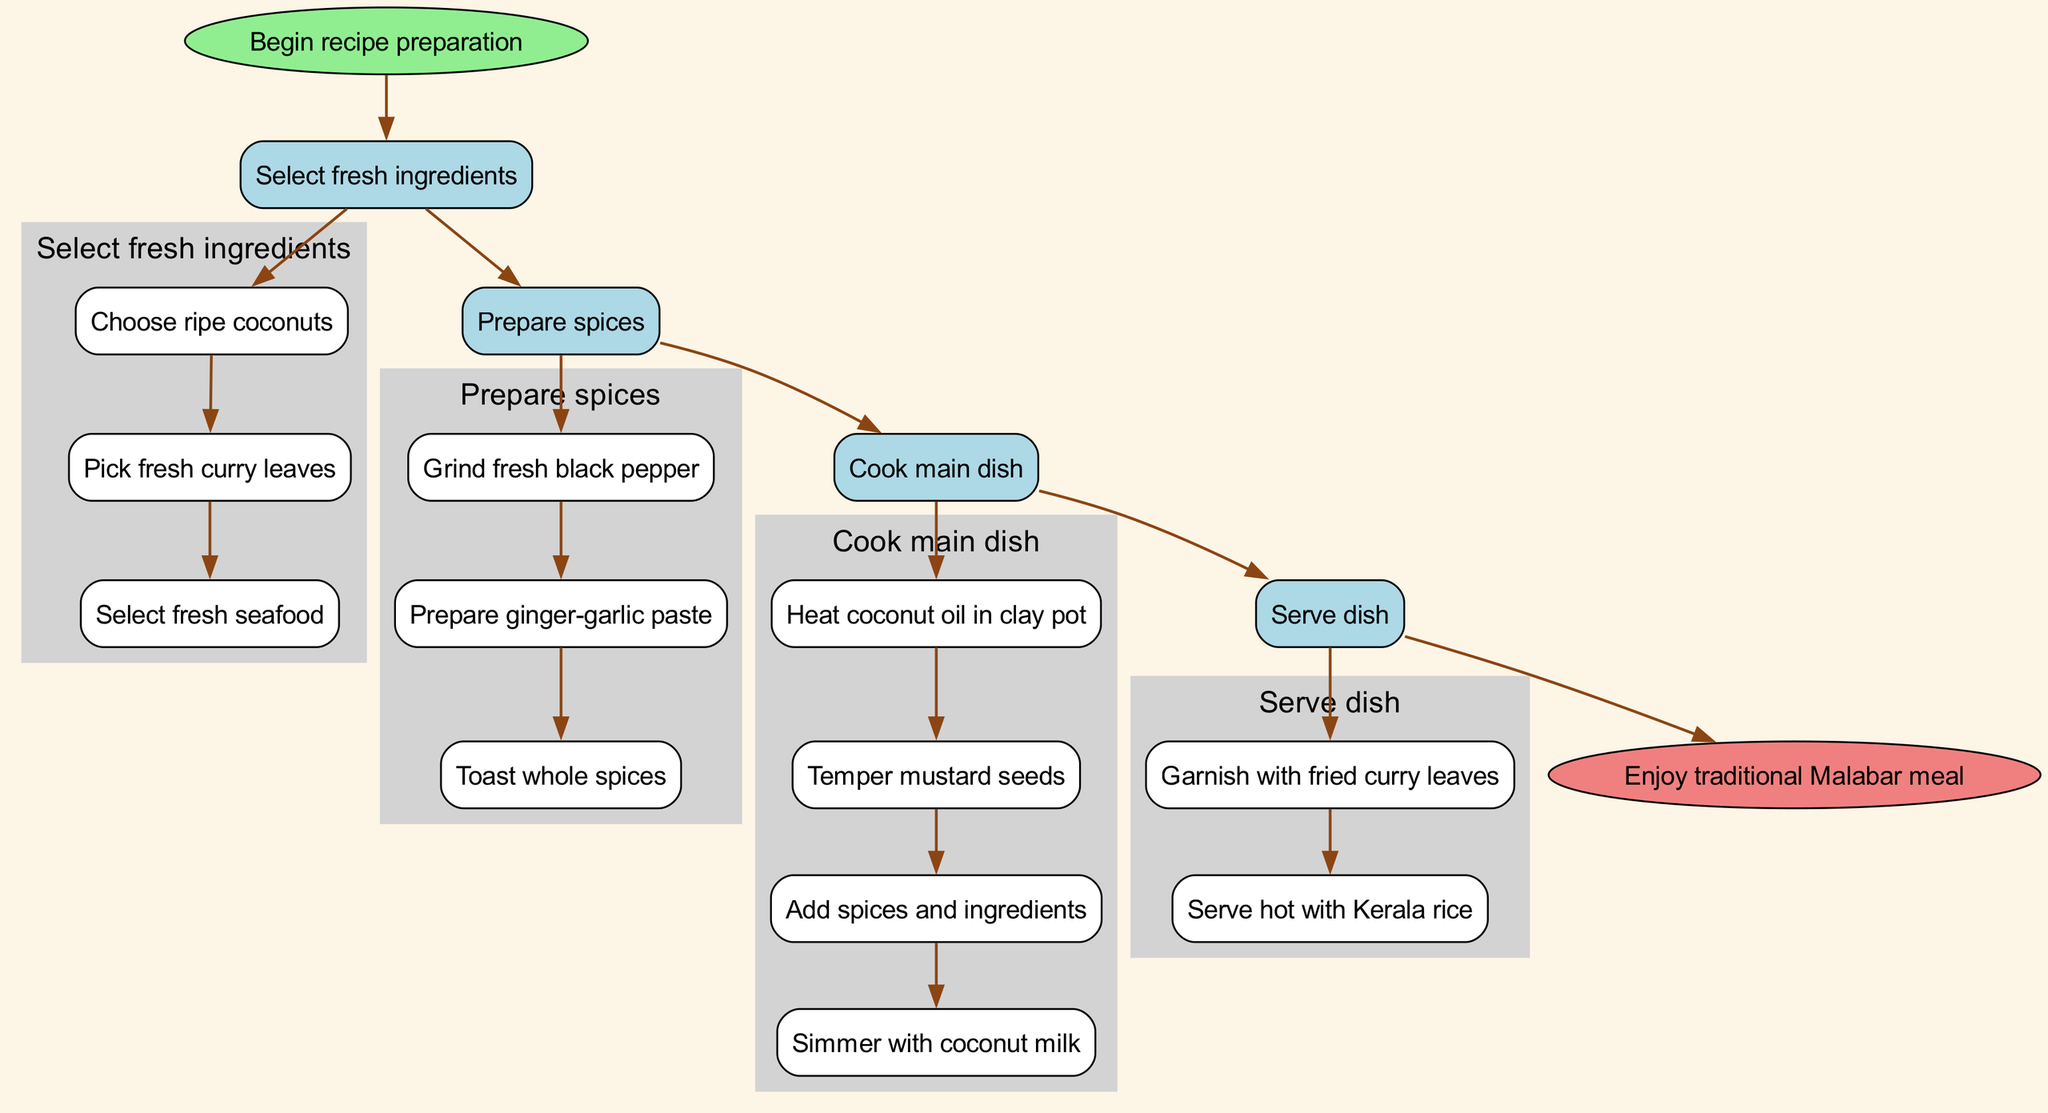What is the first step in the recipe preparation? The diagram starts with the node labeled "Begin recipe preparation," which connects to the first main step labeled "Select fresh ingredients." Therefore, the first step in the recipe preparation is to select fresh ingredients.
Answer: Select fresh ingredients How many substeps are there in preparing spices? Under the step "Prepare spices," there are three listed substeps: "Grind fresh black pepper," "Prepare ginger-garlic paste," and "Toast whole spices." Therefore, there are three substeps in preparing spices.
Answer: Three What cooking method is used in cooking the main dish? In the "Cook main dish" step, the method involves several actions like heating coconut oil in a clay pot and tempering mustard seeds. The keyword "Cook" indicates that the cooking method is utilized in this step.
Answer: Cooking Which ingredient is used for garnishing the dish? The step "Serve dish" contains a substep that mentions "Garnish with fried curry leaves." Therefore, fried curry leaves are used for garnishing the dish.
Answer: Fried curry leaves How many main steps are in the diagram? The diagram includes four main steps: "Select fresh ingredients," "Prepare spices," "Cook main dish," and "Serve dish." Counting these main steps, there are four in total.
Answer: Four What connects the last main step to the end nod? The last main step is "Serve dish." This step connects to the end node labeled "Enjoy traditional Malabar meal" indicating the conclusion of the recipe preparation.
Answer: Serve dish Which main step follows after selecting fresh ingredients? After the step "Select fresh ingredients," the next main step in the diagram is "Prepare spices." Therefore, this is the subsequent step.
Answer: Prepare spices What type of pot is recommended for heating coconut oil? In the "Cook main dish" substep "Heat coconut oil in clay pot," it specifies that a clay pot is recommended for this action.
Answer: Clay pot What is the final outcome after following all the steps? The end node of the diagram labeled "Enjoy traditional Malabar meal" indicates that this is the ultimate outcome after completing all steps in the preparation of the recipe.
Answer: Enjoy traditional Malabar meal 